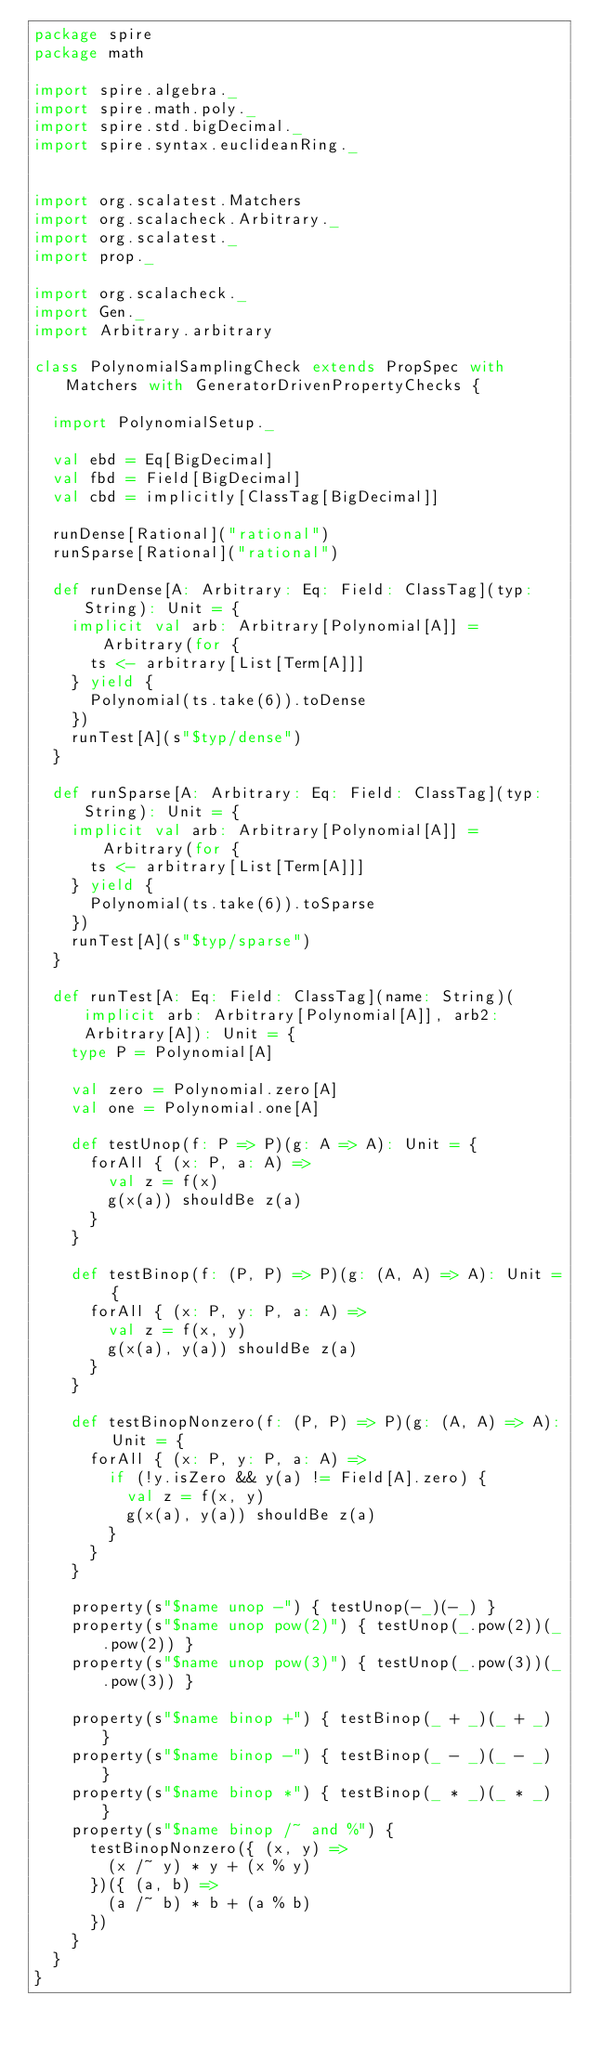<code> <loc_0><loc_0><loc_500><loc_500><_Scala_>package spire
package math

import spire.algebra._
import spire.math.poly._
import spire.std.bigDecimal._
import spire.syntax.euclideanRing._


import org.scalatest.Matchers
import org.scalacheck.Arbitrary._
import org.scalatest._
import prop._

import org.scalacheck._
import Gen._
import Arbitrary.arbitrary

class PolynomialSamplingCheck extends PropSpec with Matchers with GeneratorDrivenPropertyChecks {

  import PolynomialSetup._

  val ebd = Eq[BigDecimal]
  val fbd = Field[BigDecimal]
  val cbd = implicitly[ClassTag[BigDecimal]]

  runDense[Rational]("rational")
  runSparse[Rational]("rational")

  def runDense[A: Arbitrary: Eq: Field: ClassTag](typ: String): Unit = {
    implicit val arb: Arbitrary[Polynomial[A]] = Arbitrary(for {
      ts <- arbitrary[List[Term[A]]]
    } yield {
      Polynomial(ts.take(6)).toDense
    })
    runTest[A](s"$typ/dense")
  }

  def runSparse[A: Arbitrary: Eq: Field: ClassTag](typ: String): Unit = {
    implicit val arb: Arbitrary[Polynomial[A]] = Arbitrary(for {
      ts <- arbitrary[List[Term[A]]]
    } yield {
      Polynomial(ts.take(6)).toSparse
    })
    runTest[A](s"$typ/sparse")
  }

  def runTest[A: Eq: Field: ClassTag](name: String)(implicit arb: Arbitrary[Polynomial[A]], arb2: Arbitrary[A]): Unit = {
    type P = Polynomial[A]

    val zero = Polynomial.zero[A]
    val one = Polynomial.one[A]

    def testUnop(f: P => P)(g: A => A): Unit = {
      forAll { (x: P, a: A) =>
        val z = f(x)
        g(x(a)) shouldBe z(a)
      }
    }

    def testBinop(f: (P, P) => P)(g: (A, A) => A): Unit = {
      forAll { (x: P, y: P, a: A) =>
        val z = f(x, y)
        g(x(a), y(a)) shouldBe z(a)
      }
    }

    def testBinopNonzero(f: (P, P) => P)(g: (A, A) => A): Unit = {
      forAll { (x: P, y: P, a: A) =>
        if (!y.isZero && y(a) != Field[A].zero) {
          val z = f(x, y)
          g(x(a), y(a)) shouldBe z(a)
        }
      }
    }

    property(s"$name unop -") { testUnop(-_)(-_) }
    property(s"$name unop pow(2)") { testUnop(_.pow(2))(_.pow(2)) }
    property(s"$name unop pow(3)") { testUnop(_.pow(3))(_.pow(3)) }

    property(s"$name binop +") { testBinop(_ + _)(_ + _) }
    property(s"$name binop -") { testBinop(_ - _)(_ - _) }
    property(s"$name binop *") { testBinop(_ * _)(_ * _) }
    property(s"$name binop /~ and %") {
      testBinopNonzero({ (x, y) =>
        (x /~ y) * y + (x % y)
      })({ (a, b) =>
        (a /~ b) * b + (a % b)
      })
    }
  }
}
</code> 